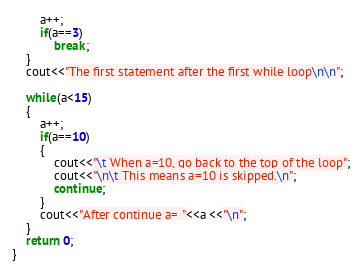Convert code to text. <code><loc_0><loc_0><loc_500><loc_500><_C++_>		a++;
		if(a==3)
			break;
	}
	cout<<"The first statement after the first while loop\n\n";

	while(a<15)
	{
		a++;
		if(a==10)
		{
			cout<<"\t When a=10, go back to the top of the loop";
			cout<<"\n\t This means a=10 is skipped.\n";
			continue;
		}
		cout<<"After continue a= "<<a <<"\n";
	}
	return 0;
}</code> 